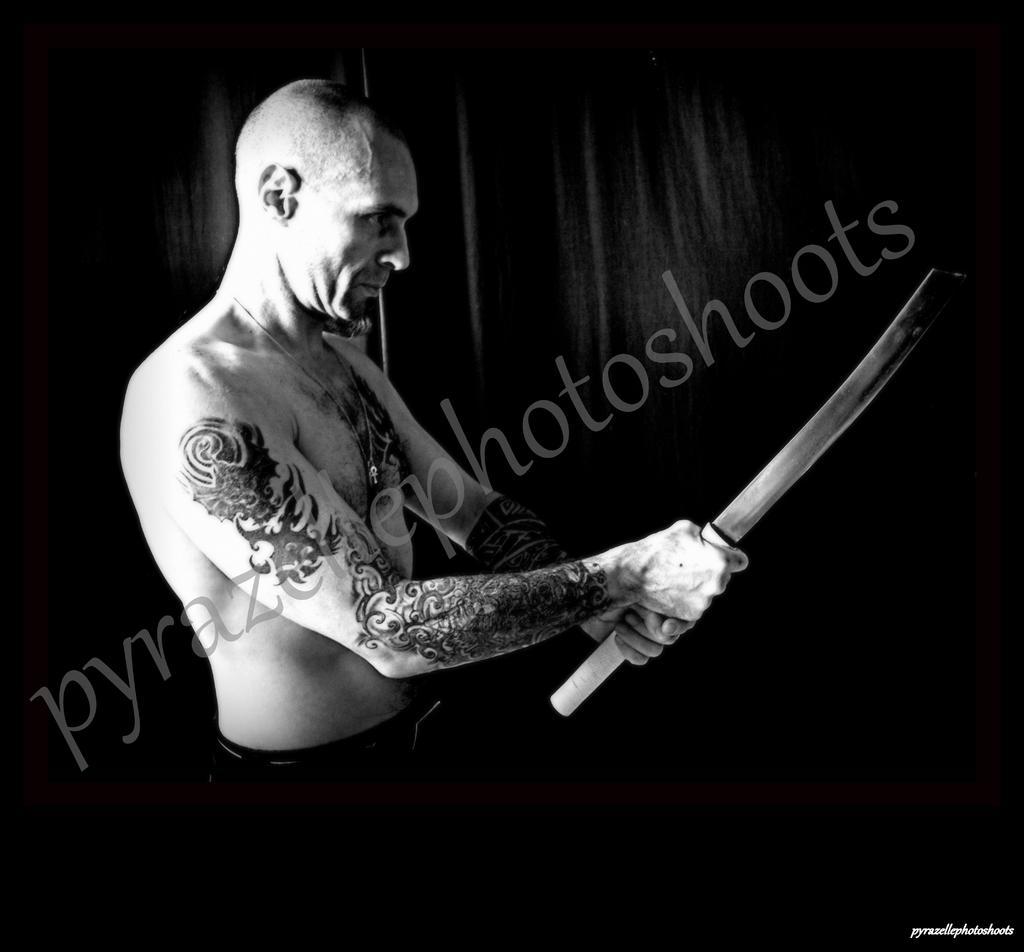In one or two sentences, can you explain what this image depicts? This is a black and white picture. Here we can see a man holding a weapon with his hands. 